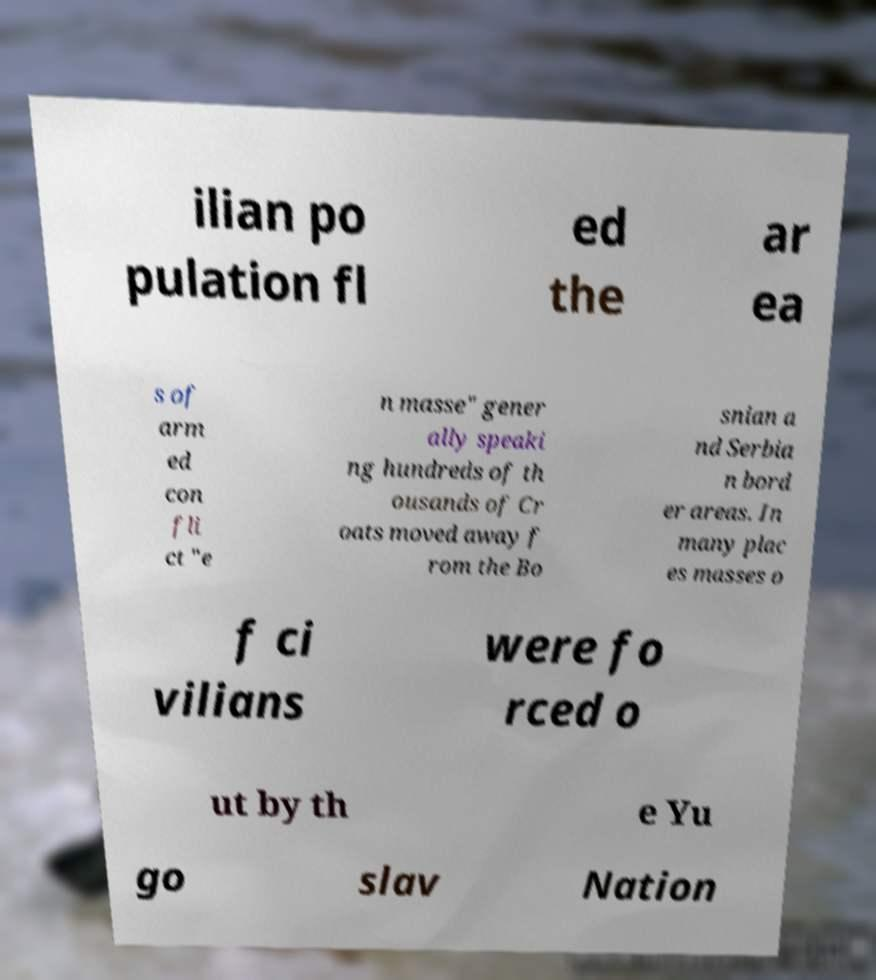What messages or text are displayed in this image? I need them in a readable, typed format. ilian po pulation fl ed the ar ea s of arm ed con fli ct "e n masse" gener ally speaki ng hundreds of th ousands of Cr oats moved away f rom the Bo snian a nd Serbia n bord er areas. In many plac es masses o f ci vilians were fo rced o ut by th e Yu go slav Nation 